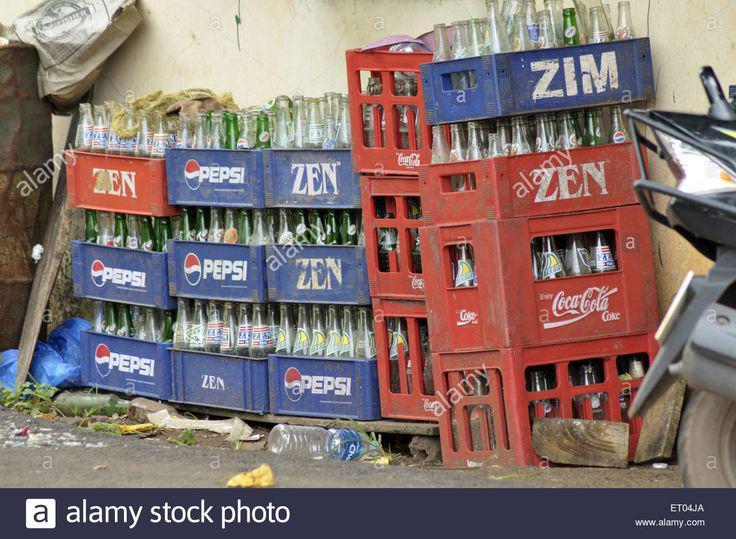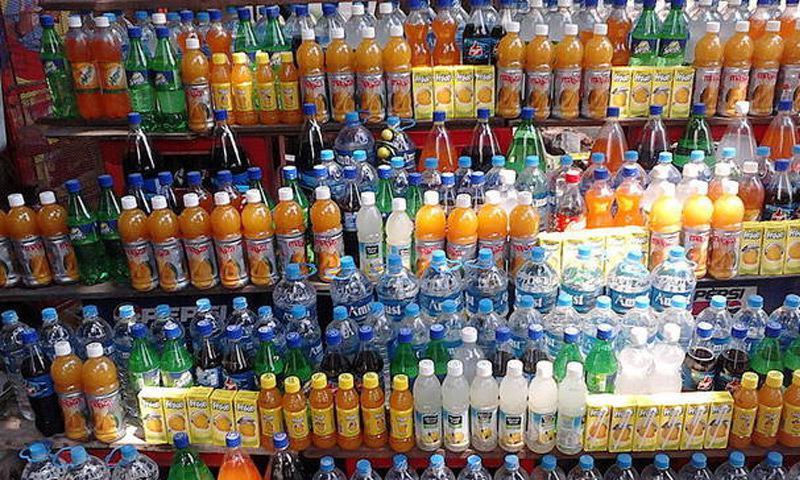The first image is the image on the left, the second image is the image on the right. Evaluate the accuracy of this statement regarding the images: "All the bottles are full.". Is it true? Answer yes or no. No. The first image is the image on the left, the second image is the image on the right. Examine the images to the left and right. Is the description "Some of the soda bottles are in plastic crates." accurate? Answer yes or no. Yes. 